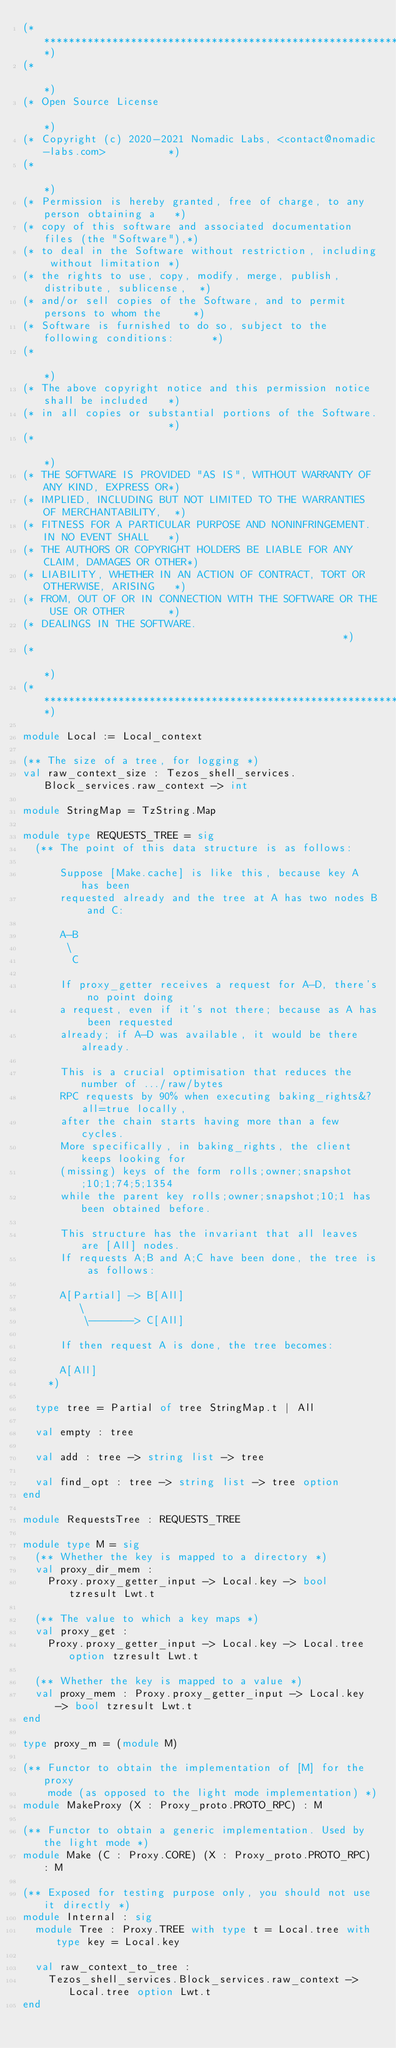Convert code to text. <code><loc_0><loc_0><loc_500><loc_500><_OCaml_>(*****************************************************************************)
(*                                                                           *)
(* Open Source License                                                       *)
(* Copyright (c) 2020-2021 Nomadic Labs, <contact@nomadic-labs.com>          *)
(*                                                                           *)
(* Permission is hereby granted, free of charge, to any person obtaining a   *)
(* copy of this software and associated documentation files (the "Software"),*)
(* to deal in the Software without restriction, including without limitation *)
(* the rights to use, copy, modify, merge, publish, distribute, sublicense,  *)
(* and/or sell copies of the Software, and to permit persons to whom the     *)
(* Software is furnished to do so, subject to the following conditions:      *)
(*                                                                           *)
(* The above copyright notice and this permission notice shall be included   *)
(* in all copies or substantial portions of the Software.                    *)
(*                                                                           *)
(* THE SOFTWARE IS PROVIDED "AS IS", WITHOUT WARRANTY OF ANY KIND, EXPRESS OR*)
(* IMPLIED, INCLUDING BUT NOT LIMITED TO THE WARRANTIES OF MERCHANTABILITY,  *)
(* FITNESS FOR A PARTICULAR PURPOSE AND NONINFRINGEMENT. IN NO EVENT SHALL   *)
(* THE AUTHORS OR COPYRIGHT HOLDERS BE LIABLE FOR ANY CLAIM, DAMAGES OR OTHER*)
(* LIABILITY, WHETHER IN AN ACTION OF CONTRACT, TORT OR OTHERWISE, ARISING   *)
(* FROM, OUT OF OR IN CONNECTION WITH THE SOFTWARE OR THE USE OR OTHER       *)
(* DEALINGS IN THE SOFTWARE.                                                 *)
(*                                                                           *)
(*****************************************************************************)

module Local := Local_context

(** The size of a tree, for logging *)
val raw_context_size : Tezos_shell_services.Block_services.raw_context -> int

module StringMap = TzString.Map

module type REQUESTS_TREE = sig
  (** The point of this data structure is as follows:

      Suppose [Make.cache] is like this, because key A has been
      requested already and the tree at A has two nodes B and C:

      A-B
       \
        C

      If proxy_getter receives a request for A-D, there's no point doing
      a request, even if it's not there; because as A has been requested
      already; if A-D was available, it would be there already.

      This is a crucial optimisation that reduces the number of .../raw/bytes
      RPC requests by 90% when executing baking_rights&?all=true locally,
      after the chain starts having more than a few cycles.
      More specifically, in baking_rights, the client keeps looking for
      (missing) keys of the form rolls;owner;snapshot;10;1;74;5;1354
      while the parent key rolls;owner;snapshot;10;1 has been obtained before.

      This structure has the invariant that all leaves are [All] nodes.
      If requests A;B and A;C have been done, the tree is as follows:

      A[Partial] -> B[All]
         \
          \-------> C[All]

      If then request A is done, the tree becomes:

      A[All]
    *)

  type tree = Partial of tree StringMap.t | All

  val empty : tree

  val add : tree -> string list -> tree

  val find_opt : tree -> string list -> tree option
end

module RequestsTree : REQUESTS_TREE

module type M = sig
  (** Whether the key is mapped to a directory *)
  val proxy_dir_mem :
    Proxy.proxy_getter_input -> Local.key -> bool tzresult Lwt.t

  (** The value to which a key maps *)
  val proxy_get :
    Proxy.proxy_getter_input -> Local.key -> Local.tree option tzresult Lwt.t

  (** Whether the key is mapped to a value *)
  val proxy_mem : Proxy.proxy_getter_input -> Local.key -> bool tzresult Lwt.t
end

type proxy_m = (module M)

(** Functor to obtain the implementation of [M] for the proxy
    mode (as opposed to the light mode implementation) *)
module MakeProxy (X : Proxy_proto.PROTO_RPC) : M

(** Functor to obtain a generic implementation. Used by the light mode *)
module Make (C : Proxy.CORE) (X : Proxy_proto.PROTO_RPC) : M

(** Exposed for testing purpose only, you should not use it directly *)
module Internal : sig
  module Tree : Proxy.TREE with type t = Local.tree with type key = Local.key

  val raw_context_to_tree :
    Tezos_shell_services.Block_services.raw_context -> Local.tree option Lwt.t
end
</code> 